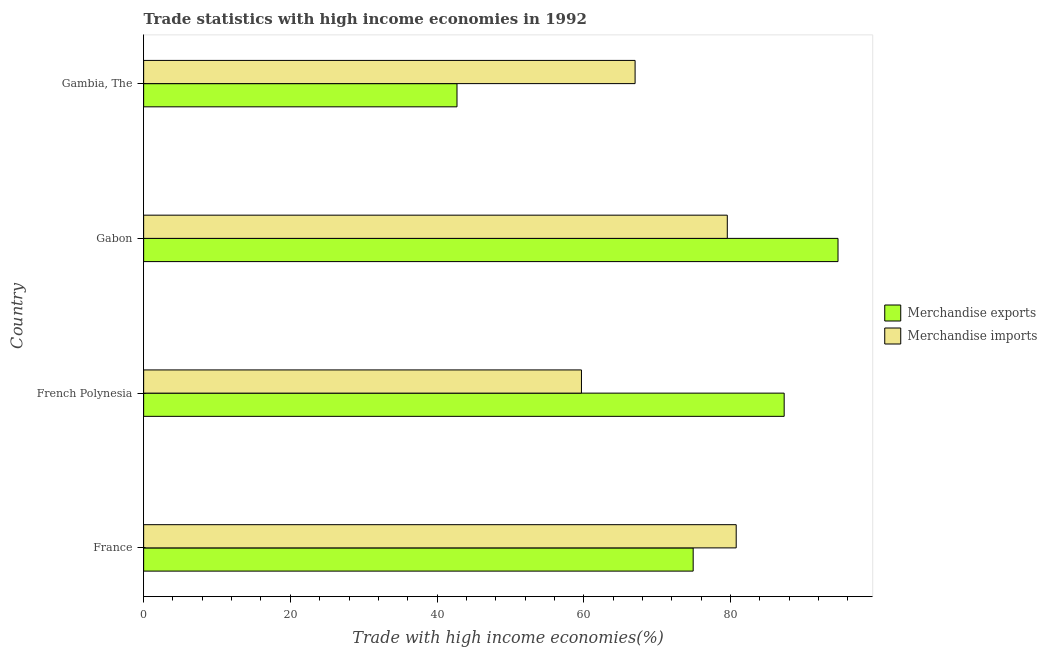How many different coloured bars are there?
Provide a short and direct response. 2. How many groups of bars are there?
Your answer should be compact. 4. Are the number of bars per tick equal to the number of legend labels?
Your answer should be compact. Yes. What is the label of the 2nd group of bars from the top?
Provide a short and direct response. Gabon. What is the merchandise exports in Gabon?
Keep it short and to the point. 94.68. Across all countries, what is the maximum merchandise imports?
Provide a short and direct response. 80.8. Across all countries, what is the minimum merchandise imports?
Offer a very short reply. 59.7. In which country was the merchandise exports minimum?
Your answer should be very brief. Gambia, The. What is the total merchandise exports in the graph?
Offer a very short reply. 299.68. What is the difference between the merchandise imports in France and that in Gabon?
Provide a succinct answer. 1.22. What is the difference between the merchandise exports in Gambia, The and the merchandise imports in French Polynesia?
Give a very brief answer. -16.97. What is the average merchandise exports per country?
Offer a terse response. 74.92. What is the difference between the merchandise exports and merchandise imports in France?
Offer a very short reply. -5.87. In how many countries, is the merchandise imports greater than 84 %?
Offer a terse response. 0. What is the ratio of the merchandise exports in France to that in Gabon?
Your response must be concise. 0.79. Is the merchandise imports in French Polynesia less than that in Gambia, The?
Your response must be concise. Yes. What is the difference between the highest and the second highest merchandise imports?
Provide a succinct answer. 1.22. What is the difference between the highest and the lowest merchandise exports?
Keep it short and to the point. 51.95. What does the 1st bar from the top in Gabon represents?
Provide a succinct answer. Merchandise imports. What does the 2nd bar from the bottom in French Polynesia represents?
Your answer should be compact. Merchandise imports. Are all the bars in the graph horizontal?
Make the answer very short. Yes. What is the title of the graph?
Your response must be concise. Trade statistics with high income economies in 1992. What is the label or title of the X-axis?
Ensure brevity in your answer.  Trade with high income economies(%). What is the Trade with high income economies(%) of Merchandise exports in France?
Ensure brevity in your answer.  74.93. What is the Trade with high income economies(%) in Merchandise imports in France?
Offer a terse response. 80.8. What is the Trade with high income economies(%) in Merchandise exports in French Polynesia?
Give a very brief answer. 87.34. What is the Trade with high income economies(%) of Merchandise imports in French Polynesia?
Offer a terse response. 59.7. What is the Trade with high income economies(%) in Merchandise exports in Gabon?
Your answer should be compact. 94.68. What is the Trade with high income economies(%) of Merchandise imports in Gabon?
Your answer should be compact. 79.58. What is the Trade with high income economies(%) of Merchandise exports in Gambia, The?
Give a very brief answer. 42.73. What is the Trade with high income economies(%) in Merchandise imports in Gambia, The?
Your answer should be very brief. 67.01. Across all countries, what is the maximum Trade with high income economies(%) in Merchandise exports?
Provide a short and direct response. 94.68. Across all countries, what is the maximum Trade with high income economies(%) in Merchandise imports?
Make the answer very short. 80.8. Across all countries, what is the minimum Trade with high income economies(%) of Merchandise exports?
Give a very brief answer. 42.73. Across all countries, what is the minimum Trade with high income economies(%) of Merchandise imports?
Your answer should be compact. 59.7. What is the total Trade with high income economies(%) of Merchandise exports in the graph?
Give a very brief answer. 299.68. What is the total Trade with high income economies(%) of Merchandise imports in the graph?
Ensure brevity in your answer.  287.09. What is the difference between the Trade with high income economies(%) in Merchandise exports in France and that in French Polynesia?
Offer a terse response. -12.41. What is the difference between the Trade with high income economies(%) in Merchandise imports in France and that in French Polynesia?
Your response must be concise. 21.1. What is the difference between the Trade with high income economies(%) in Merchandise exports in France and that in Gabon?
Provide a short and direct response. -19.75. What is the difference between the Trade with high income economies(%) in Merchandise imports in France and that in Gabon?
Provide a short and direct response. 1.22. What is the difference between the Trade with high income economies(%) of Merchandise exports in France and that in Gambia, The?
Keep it short and to the point. 32.2. What is the difference between the Trade with high income economies(%) in Merchandise imports in France and that in Gambia, The?
Offer a very short reply. 13.79. What is the difference between the Trade with high income economies(%) in Merchandise exports in French Polynesia and that in Gabon?
Your response must be concise. -7.34. What is the difference between the Trade with high income economies(%) of Merchandise imports in French Polynesia and that in Gabon?
Offer a terse response. -19.89. What is the difference between the Trade with high income economies(%) in Merchandise exports in French Polynesia and that in Gambia, The?
Your answer should be very brief. 44.61. What is the difference between the Trade with high income economies(%) in Merchandise imports in French Polynesia and that in Gambia, The?
Provide a short and direct response. -7.32. What is the difference between the Trade with high income economies(%) in Merchandise exports in Gabon and that in Gambia, The?
Provide a short and direct response. 51.95. What is the difference between the Trade with high income economies(%) in Merchandise imports in Gabon and that in Gambia, The?
Offer a very short reply. 12.57. What is the difference between the Trade with high income economies(%) in Merchandise exports in France and the Trade with high income economies(%) in Merchandise imports in French Polynesia?
Provide a short and direct response. 15.23. What is the difference between the Trade with high income economies(%) in Merchandise exports in France and the Trade with high income economies(%) in Merchandise imports in Gabon?
Your answer should be compact. -4.65. What is the difference between the Trade with high income economies(%) of Merchandise exports in France and the Trade with high income economies(%) of Merchandise imports in Gambia, The?
Provide a succinct answer. 7.92. What is the difference between the Trade with high income economies(%) in Merchandise exports in French Polynesia and the Trade with high income economies(%) in Merchandise imports in Gabon?
Your answer should be compact. 7.76. What is the difference between the Trade with high income economies(%) of Merchandise exports in French Polynesia and the Trade with high income economies(%) of Merchandise imports in Gambia, The?
Keep it short and to the point. 20.33. What is the difference between the Trade with high income economies(%) in Merchandise exports in Gabon and the Trade with high income economies(%) in Merchandise imports in Gambia, The?
Provide a succinct answer. 27.67. What is the average Trade with high income economies(%) in Merchandise exports per country?
Make the answer very short. 74.92. What is the average Trade with high income economies(%) in Merchandise imports per country?
Your answer should be very brief. 71.77. What is the difference between the Trade with high income economies(%) of Merchandise exports and Trade with high income economies(%) of Merchandise imports in France?
Provide a short and direct response. -5.87. What is the difference between the Trade with high income economies(%) in Merchandise exports and Trade with high income economies(%) in Merchandise imports in French Polynesia?
Ensure brevity in your answer.  27.64. What is the difference between the Trade with high income economies(%) of Merchandise exports and Trade with high income economies(%) of Merchandise imports in Gabon?
Give a very brief answer. 15.1. What is the difference between the Trade with high income economies(%) in Merchandise exports and Trade with high income economies(%) in Merchandise imports in Gambia, The?
Give a very brief answer. -24.29. What is the ratio of the Trade with high income economies(%) of Merchandise exports in France to that in French Polynesia?
Your response must be concise. 0.86. What is the ratio of the Trade with high income economies(%) in Merchandise imports in France to that in French Polynesia?
Keep it short and to the point. 1.35. What is the ratio of the Trade with high income economies(%) of Merchandise exports in France to that in Gabon?
Your answer should be compact. 0.79. What is the ratio of the Trade with high income economies(%) in Merchandise imports in France to that in Gabon?
Make the answer very short. 1.02. What is the ratio of the Trade with high income economies(%) of Merchandise exports in France to that in Gambia, The?
Keep it short and to the point. 1.75. What is the ratio of the Trade with high income economies(%) of Merchandise imports in France to that in Gambia, The?
Your answer should be compact. 1.21. What is the ratio of the Trade with high income economies(%) of Merchandise exports in French Polynesia to that in Gabon?
Provide a short and direct response. 0.92. What is the ratio of the Trade with high income economies(%) in Merchandise imports in French Polynesia to that in Gabon?
Give a very brief answer. 0.75. What is the ratio of the Trade with high income economies(%) of Merchandise exports in French Polynesia to that in Gambia, The?
Provide a succinct answer. 2.04. What is the ratio of the Trade with high income economies(%) in Merchandise imports in French Polynesia to that in Gambia, The?
Your answer should be very brief. 0.89. What is the ratio of the Trade with high income economies(%) of Merchandise exports in Gabon to that in Gambia, The?
Provide a short and direct response. 2.22. What is the ratio of the Trade with high income economies(%) in Merchandise imports in Gabon to that in Gambia, The?
Make the answer very short. 1.19. What is the difference between the highest and the second highest Trade with high income economies(%) in Merchandise exports?
Keep it short and to the point. 7.34. What is the difference between the highest and the second highest Trade with high income economies(%) of Merchandise imports?
Offer a terse response. 1.22. What is the difference between the highest and the lowest Trade with high income economies(%) in Merchandise exports?
Keep it short and to the point. 51.95. What is the difference between the highest and the lowest Trade with high income economies(%) of Merchandise imports?
Keep it short and to the point. 21.1. 